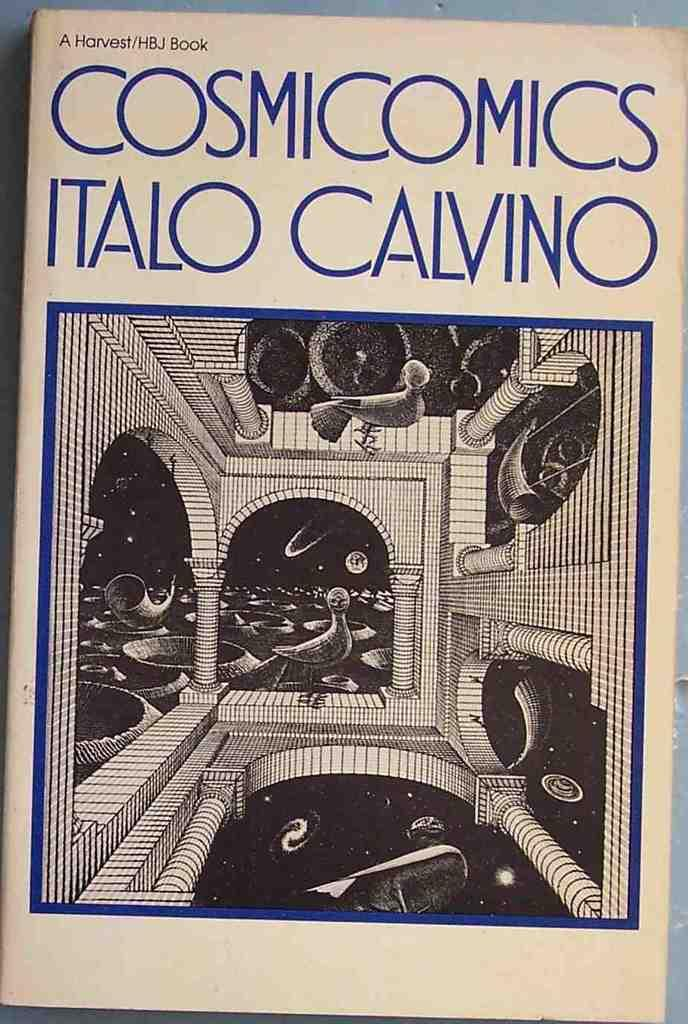<image>
Give a short and clear explanation of the subsequent image. The book 'Cosmicomics Italo Calvino' has a blue and white cover. 